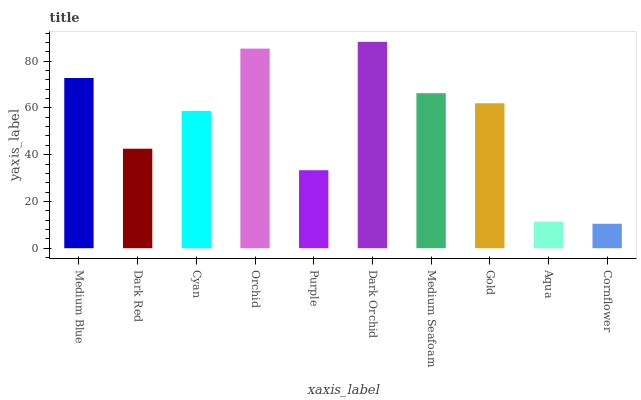Is Cornflower the minimum?
Answer yes or no. Yes. Is Dark Orchid the maximum?
Answer yes or no. Yes. Is Dark Red the minimum?
Answer yes or no. No. Is Dark Red the maximum?
Answer yes or no. No. Is Medium Blue greater than Dark Red?
Answer yes or no. Yes. Is Dark Red less than Medium Blue?
Answer yes or no. Yes. Is Dark Red greater than Medium Blue?
Answer yes or no. No. Is Medium Blue less than Dark Red?
Answer yes or no. No. Is Gold the high median?
Answer yes or no. Yes. Is Cyan the low median?
Answer yes or no. Yes. Is Orchid the high median?
Answer yes or no. No. Is Dark Red the low median?
Answer yes or no. No. 